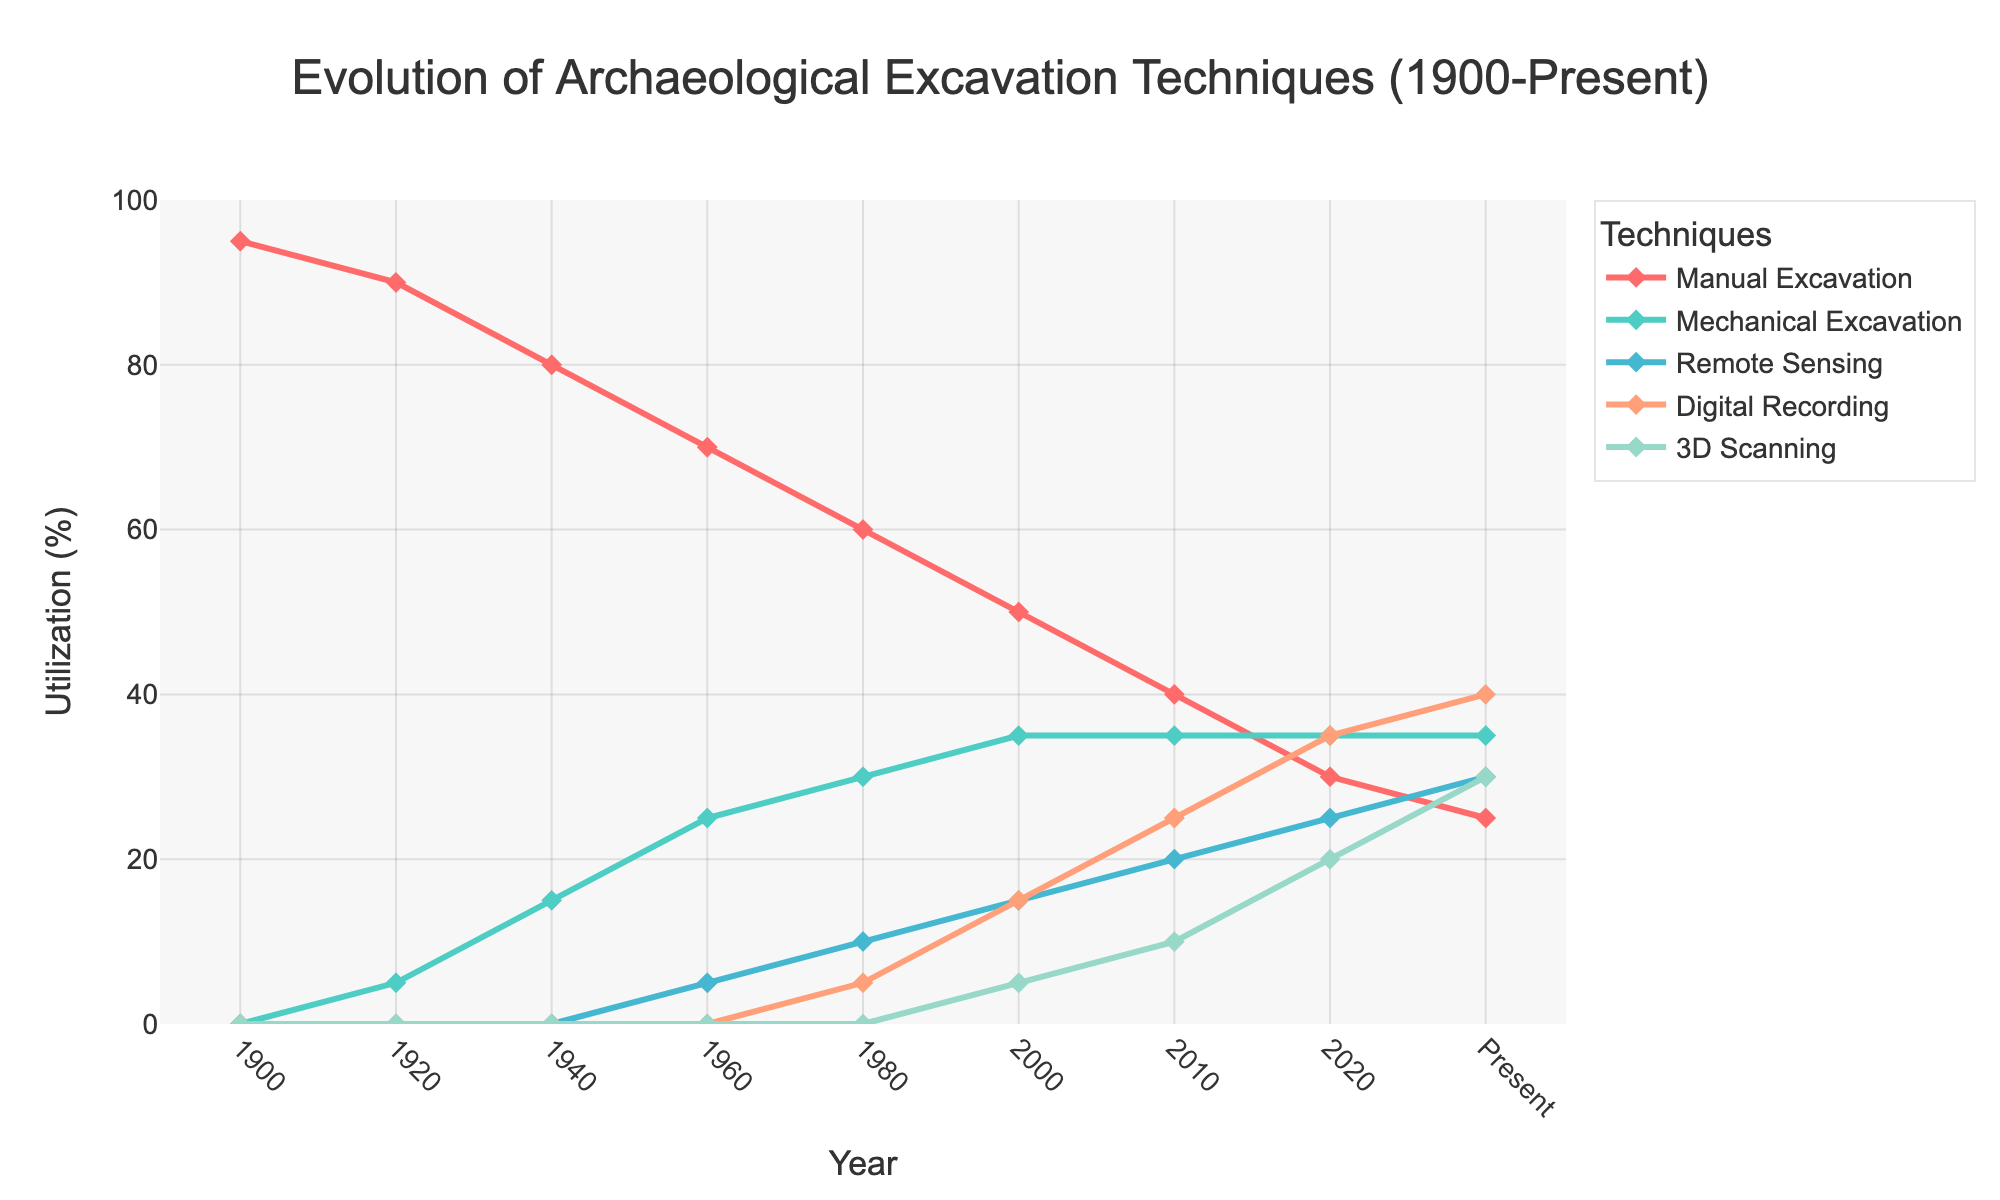What is the utilization percentage of Manual Excavation in 1920? To find the utilization percentage of Manual Excavation in 1920, locate the year 1920 on the figure and refer to the line corresponding to Manual Excavation.
Answer: 90 Which technique had the same utilization percentage from 2000 to 2020? To answer this, compare the utilization percentages of all techniques in the years 2000 and 2020. Mechanical Excavation shows the same utilization percentage of 35% in both years.
Answer: Mechanical Excavation Which technique has shown the most significant increase in utilization from 1900 to the present? Compare the utilization percentages of all techniques from 1900 to the present. Remote Sensing, Digital Recording, and 3D Scanning were not used in 1900 but have increased significantly by the present. Among these, 3D Scanning shows an increase from 0% to 30%, which is the most significant.
Answer: 3D Scanning Between which two years did Digital Recording see the highest increase in utilization percentage? To determine this, compare the changes in the utilization percentages of Digital Recording between consecutive years. The highest increase occurred between 2010 and 2020, where it went from 25% to 35%.
Answer: 2010 and 2020 What was the combined utilization percentage of Remote Sensing and Digital Recording techniques in 2000? Add the utilization percentages of Remote Sensing (15%) and Digital Recording (15%) in the year 2000.
Answer: 30% In which year did 3D Scanning become first utilized, and what was its percentage? Look for the first non-zero value in the 3D Scanning line. This occurred in 2000 with a utilization percentage of 5%.
Answer: 2000, 5% Which year marked the first appearance of Remote Sensing, and what was its percentage at that time? Check for the first non-zero value in the line corresponding to Remote Sensing. Remote Sensing first appeared in 1960 with a utilization percentage of 5%.
Answer: 1960, 5% Compare the utilization percentages of Manual Excavation and Mechanical Excavation in 2010. Which was higher, and by how much? For 2010, Manual Excavation was 40%, and Mechanical Excavation was 35%. Therefore, Manual Excavation was higher by 5%.
Answer: Manual Excavation was higher by 5% What is the trend in the utilization of Manual Excavation from 1900 to the present? The trend of Manual Excavation can be observed by following its line from 1900 to the present. It shows a consistent decline over time.
Answer: Consistent decline By how much has the utilization of Digital Recording increased from the year 2000 to the present? Compare the utilization percentage of Digital Recording in 2000 (15%) with the present (40%). The increase is 40% - 15% = 25%.
Answer: 25% 